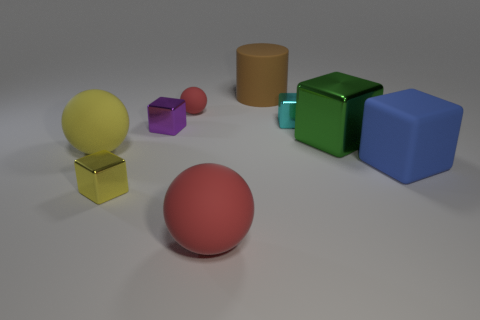What might be the purpose of arranging these objects in this setting? This composition might be created for several purposes. Primarily, it could serve as a demonstration of 3D rendering techniques, showcasing lighting, texture, and material properties. Alternatively, it could be an artist's abstract representation meant to evoke curiosity and exploration of geometric forms and their interplay with light and shadow. 